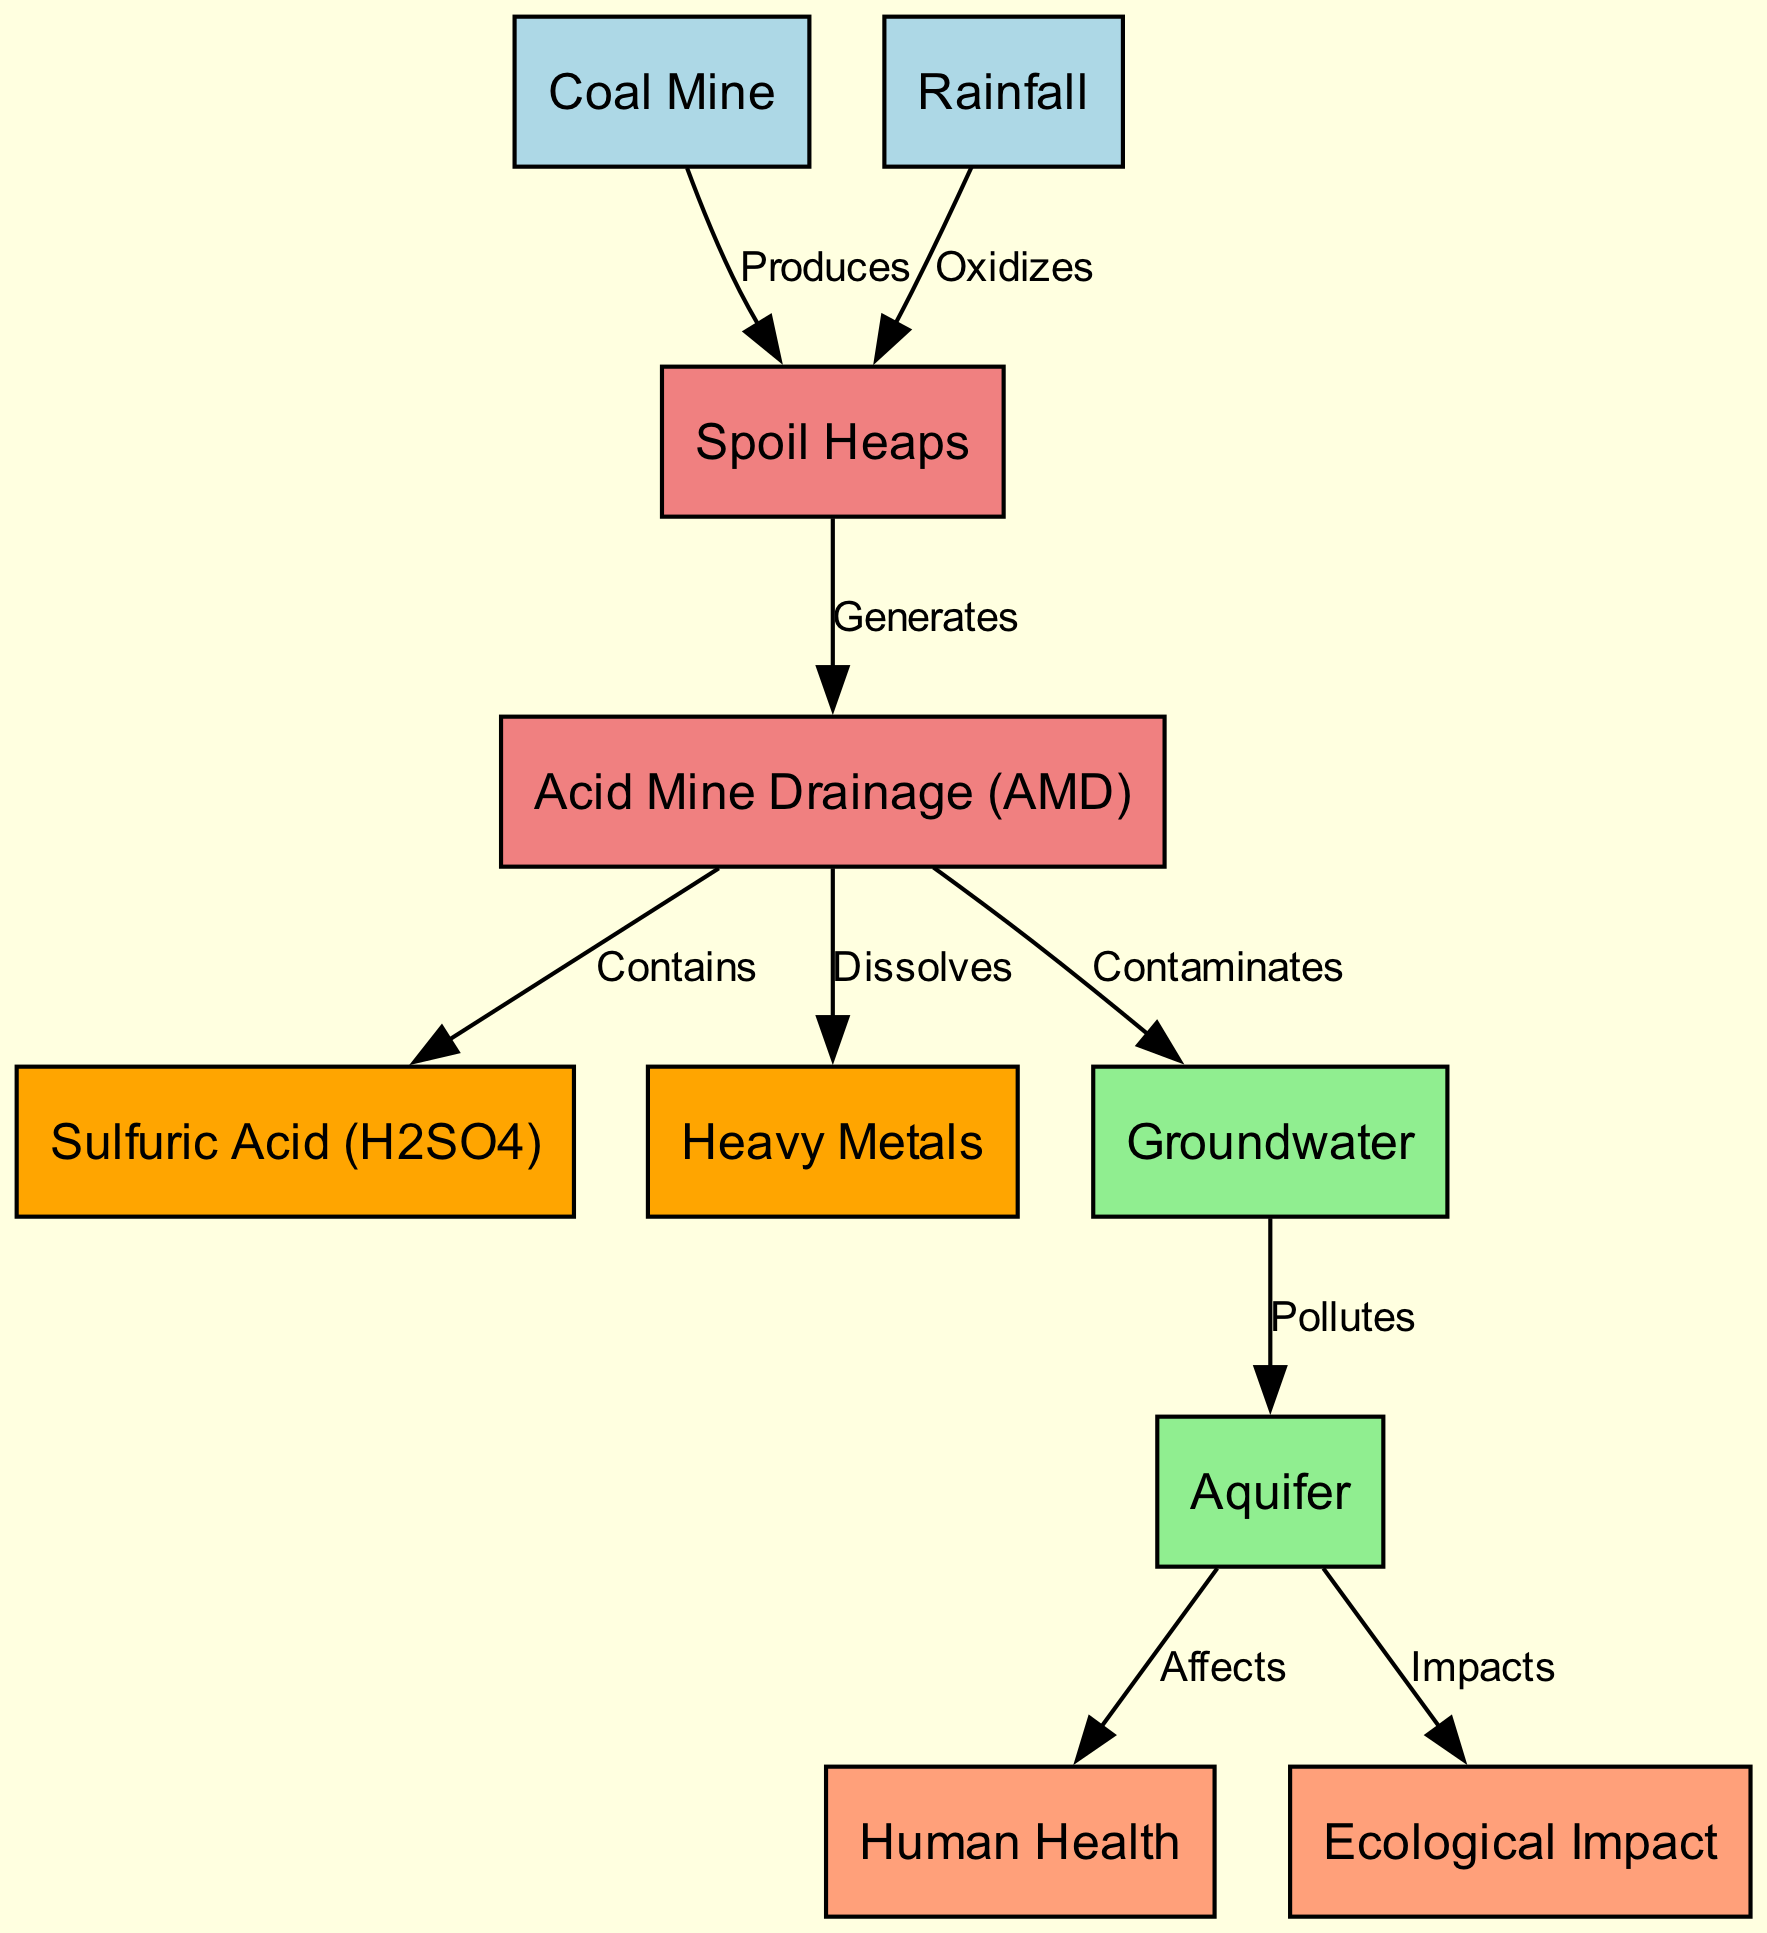What is the first node in the diagram? The first node in the diagram is "Coal Mine." This can be identified as it is placed at the top of the diagram and represents the starting point of the processes described.
Answer: Coal Mine How many major chemical entities are involved in the groundwater contamination process? In the diagram, there are two major chemical entities involved: "Sulfuric Acid" and "Heavy Metals." These entities are listed as part of the process resulting from Acid Mine Drainage.
Answer: 2 What node connects "Acid Mine Drainage" to "Groundwater"? The connection from "Acid Mine Drainage" to "Groundwater" is labeled as "Contaminates." This indicates that Acid Mine Drainage has a direct effect on groundwater quality.
Answer: Contaminates What does "Spoil Heaps" generate in the process? "Spoil Heaps" generates "Acid Mine Drainage." This can be traced by following the edge labeled "Generates" leading to the Acid Mine Drainage node, indicating that spoil heaps are a source of this contamination.
Answer: Acid Mine Drainage What is the effect of groundwater pollution on human health? The effect of groundwater pollution on human health is indicated as "Affects." This is linked via the edge from the "Aquifer" to the "Human Health" node, showing the impact water pollution has on people.
Answer: Affects How does rainfall interact with spoil heaps? Rainfall "Oxidizes" spoil heaps. This interaction is represented by the edge that connects "Rainfall" to "Spoil Heaps," illustrating how rainfall contributes to the contamination process.
Answer: Oxidizes Which process leads to the presence of heavy metals in groundwater? The presence of heavy metals in groundwater results from "Acid Mine Drainage," specifically from the edge labeled "Dissolves," which indicates that acid mine drainage is responsible for dissolving heavy metals.
Answer: Acid Mine Drainage What ecological impact is linked to the aquifer? The ecological impact linked to the aquifer is noted as "Impacts." This relationship can be seen through the connection from "Aquifer" to "Ecological Impact," highlighting a significant concern for the environment.
Answer: Impacts 